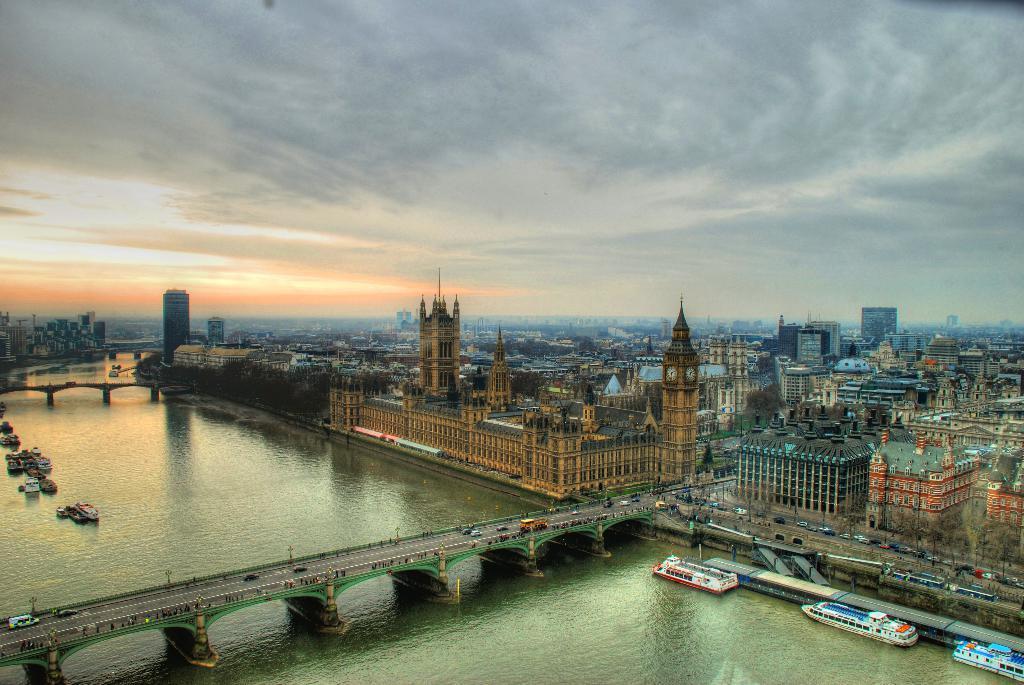How would you summarize this image in a sentence or two? In this image we can see a group of buildings with windows and a tower with a clock. We can also see a group of vehicles on the bridges and some boats on a water body. On the backside we can see the sky which looks cloudy,. 